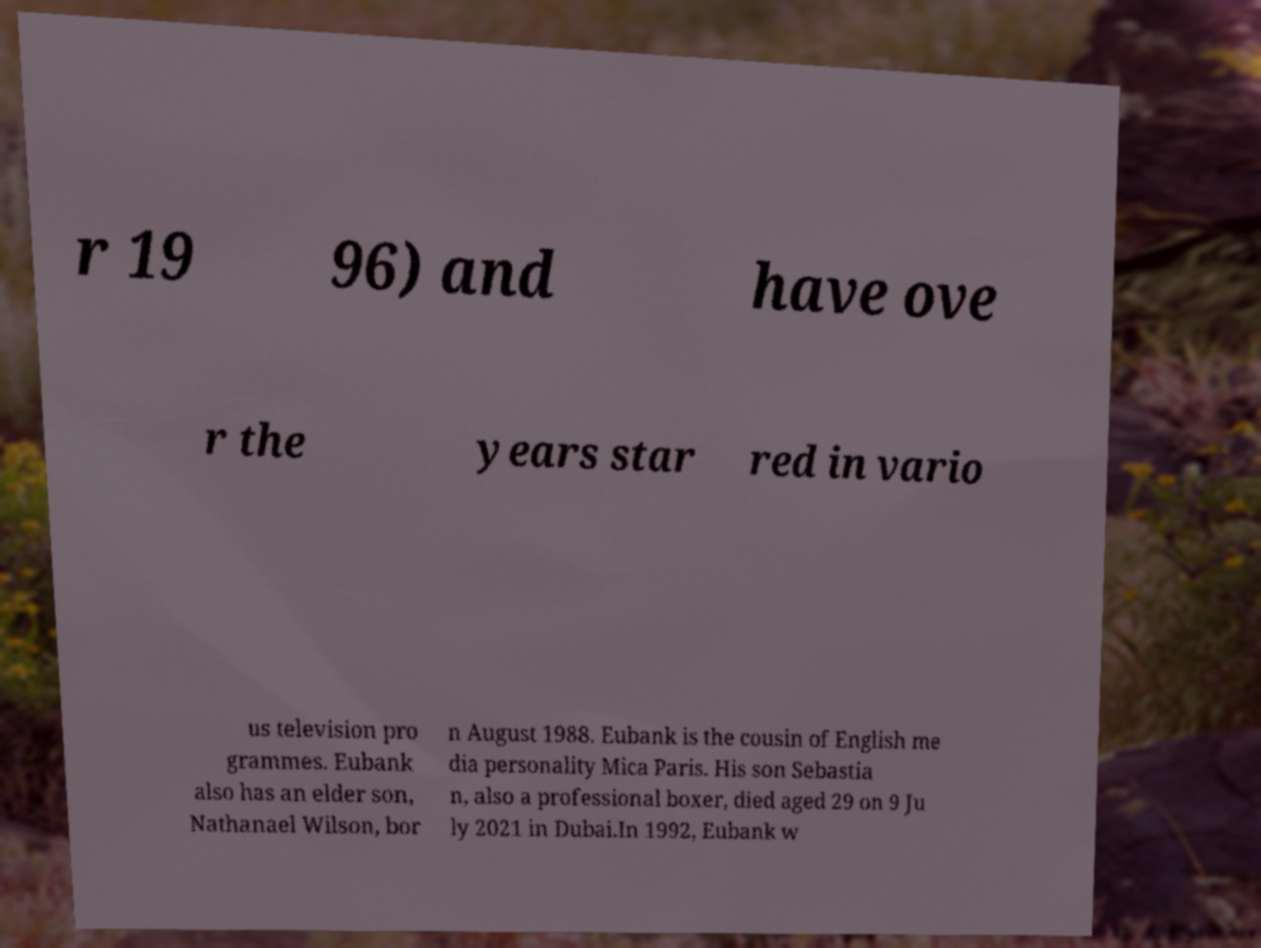What messages or text are displayed in this image? I need them in a readable, typed format. r 19 96) and have ove r the years star red in vario us television pro grammes. Eubank also has an elder son, Nathanael Wilson, bor n August 1988. Eubank is the cousin of English me dia personality Mica Paris. His son Sebastia n, also a professional boxer, died aged 29 on 9 Ju ly 2021 in Dubai.In 1992, Eubank w 